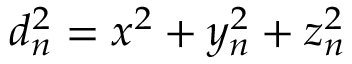<formula> <loc_0><loc_0><loc_500><loc_500>d _ { n } ^ { 2 } = x ^ { 2 } + y _ { n } ^ { 2 } + z _ { n } ^ { 2 }</formula> 